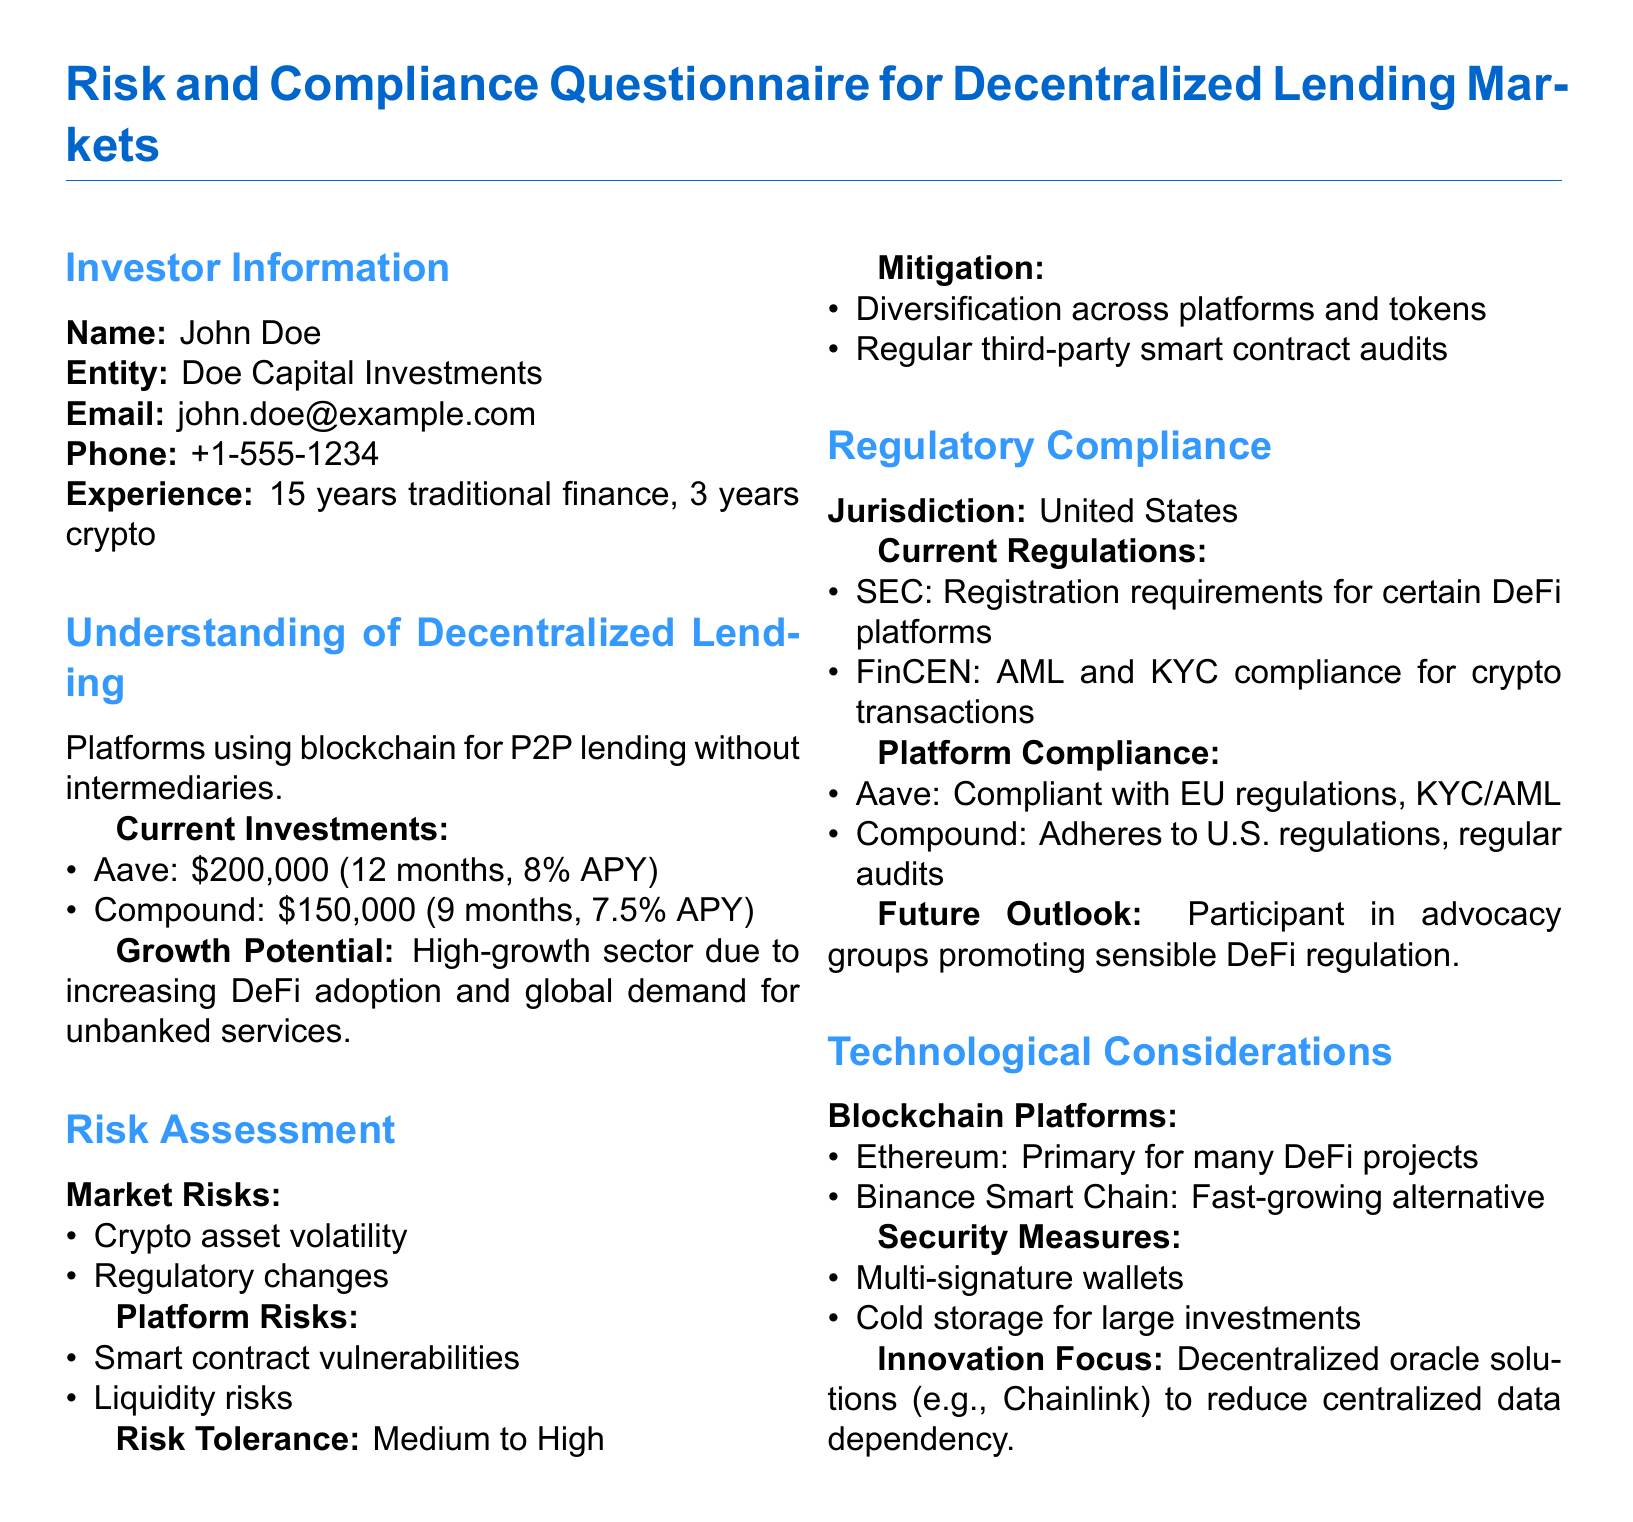what is the name of the investor? The name of the investor is found in the section detailing Investor Information.
Answer: John Doe how many years of experience does the investor have in crypto? The investor's experience in crypto is listed under the Investor Information section.
Answer: 3 years what is the total investment in Aave? The total investment in Aave can be found in the Current Investments subsection.
Answer: $200,000 what are the two main market risks identified? The two main market risks are outlined in the Risk Assessment section.
Answer: Crypto asset volatility, Regulatory changes how does the investor plan to mitigate risks? The investor's risk mitigation strategies are described in the Risk Assessment section.
Answer: Diversification across platforms and tokens, Regular third-party smart contract audits what regulations apply to decentralized lending in the United States? The current regulations affecting decentralized lending in the U.S. are specified in the Regulatory Compliance section.
Answer: SEC: Registration requirements for certain DeFi platforms, FinCEN: AML and KYC compliance for crypto transactions which blockchain platform is primarily used for many DeFi projects? The primary blockchain platform mentioned is listed in the Technological Considerations subsection.
Answer: Ethereum what security measure involves storing assets offline? The document specifies several security measures; the one regarding offline storage is mentioned in Technological Considerations.
Answer: Cold storage for large investments what is the investor's risk tolerance level? The investor's risk tolerance is stated in the Risk Assessment section.
Answer: Medium to High 